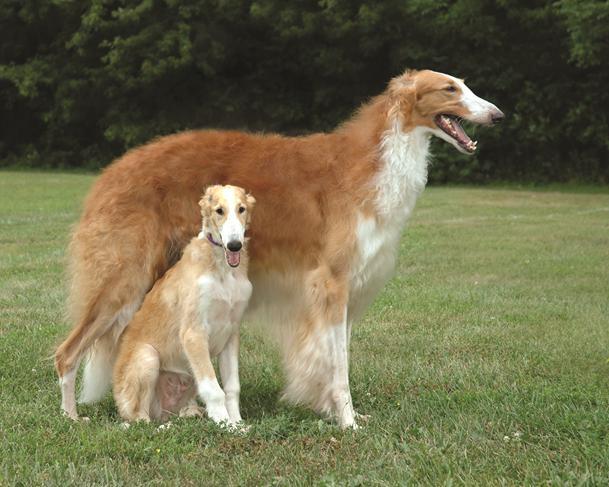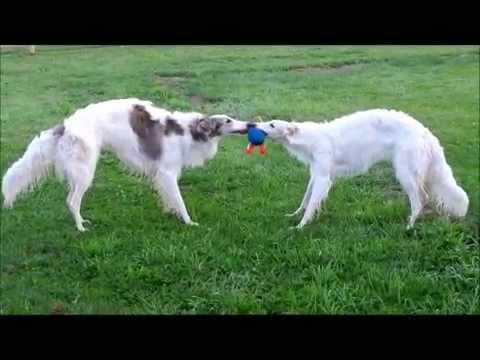The first image is the image on the left, the second image is the image on the right. For the images displayed, is the sentence "There are two dogs in the left image." factually correct? Answer yes or no. Yes. The first image is the image on the left, the second image is the image on the right. Analyze the images presented: Is the assertion "There is one dog in a grassy area in the image on the left." valid? Answer yes or no. No. The first image is the image on the left, the second image is the image on the right. Examine the images to the left and right. Is the description "An image shows a young animal of some type close to an adult hound with its body turned rightward." accurate? Answer yes or no. Yes. 